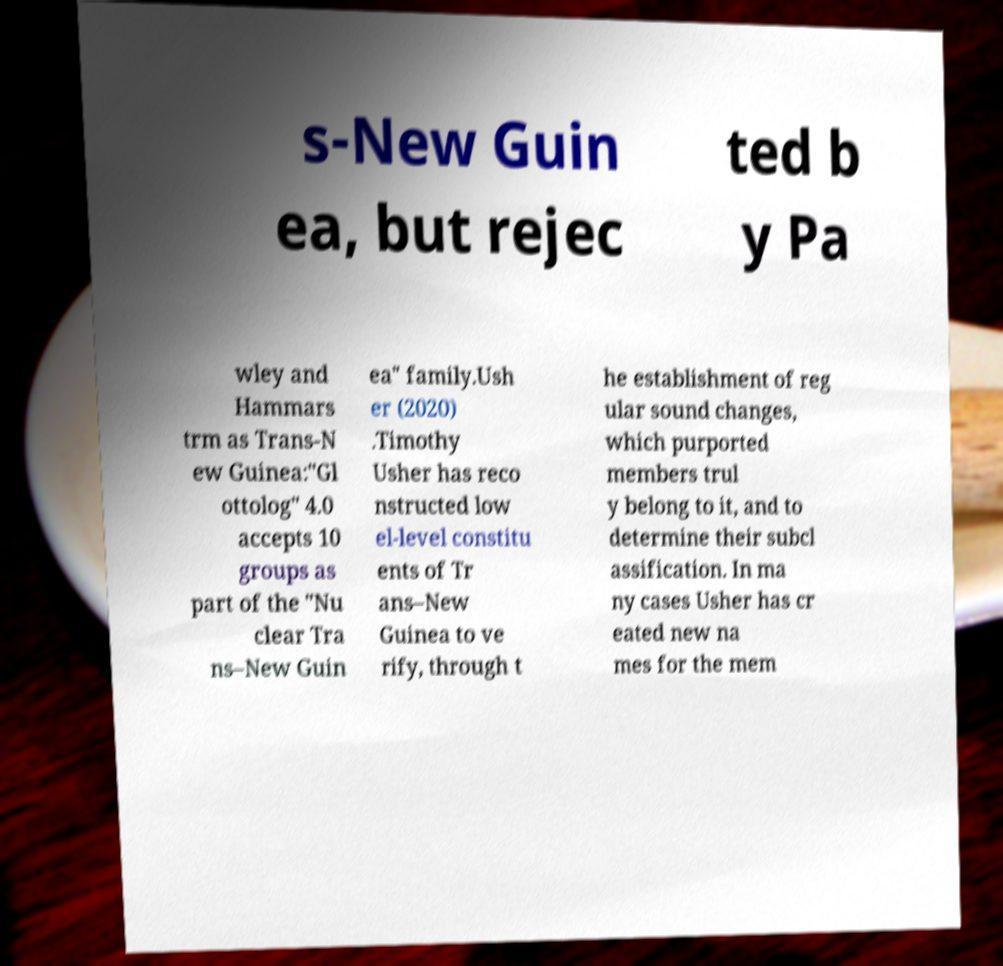There's text embedded in this image that I need extracted. Can you transcribe it verbatim? s-New Guin ea, but rejec ted b y Pa wley and Hammars trm as Trans-N ew Guinea:"Gl ottolog" 4.0 accepts 10 groups as part of the "Nu clear Tra ns–New Guin ea" family.Ush er (2020) .Timothy Usher has reco nstructed low el-level constitu ents of Tr ans–New Guinea to ve rify, through t he establishment of reg ular sound changes, which purported members trul y belong to it, and to determine their subcl assification. In ma ny cases Usher has cr eated new na mes for the mem 